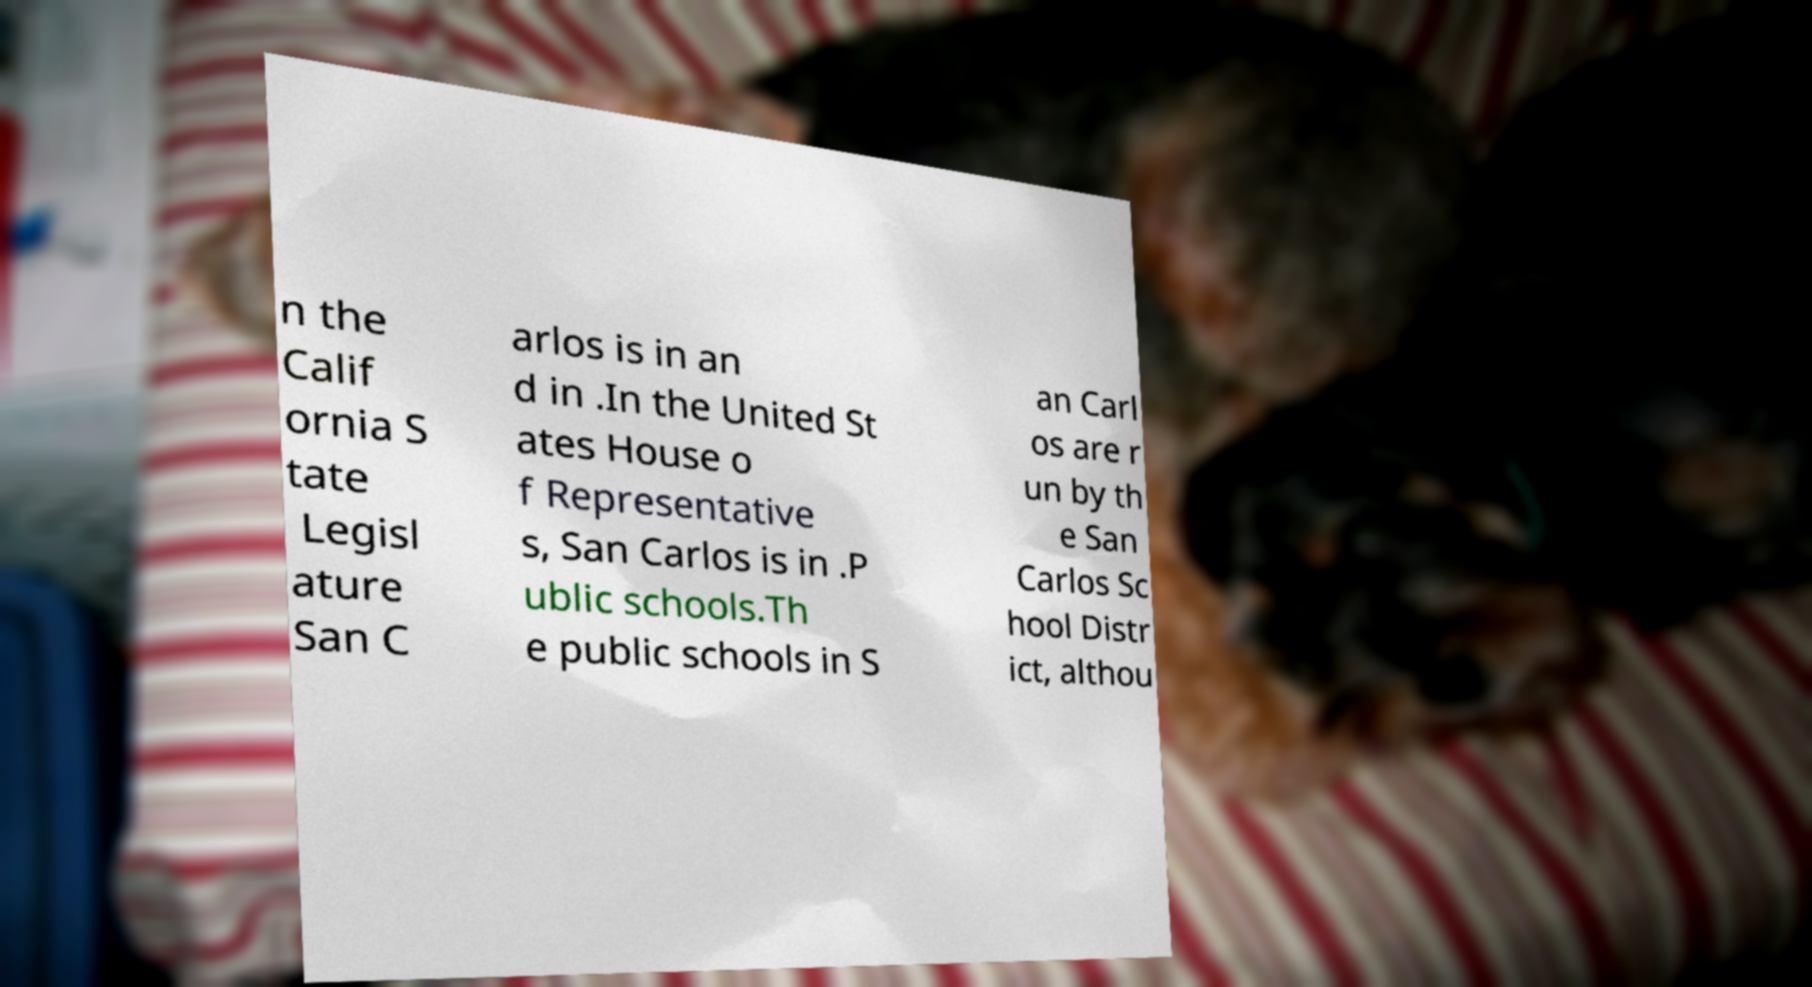Could you extract and type out the text from this image? n the Calif ornia S tate Legisl ature San C arlos is in an d in .In the United St ates House o f Representative s, San Carlos is in .P ublic schools.Th e public schools in S an Carl os are r un by th e San Carlos Sc hool Distr ict, althou 